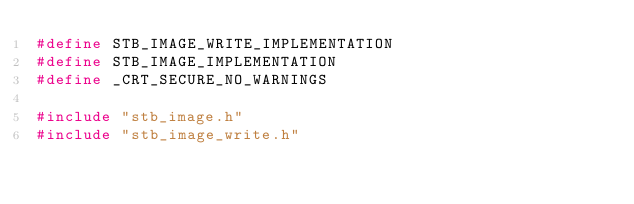Convert code to text. <code><loc_0><loc_0><loc_500><loc_500><_C++_>#define STB_IMAGE_WRITE_IMPLEMENTATION
#define STB_IMAGE_IMPLEMENTATION
#define _CRT_SECURE_NO_WARNINGS

#include "stb_image.h"
#include "stb_image_write.h"</code> 